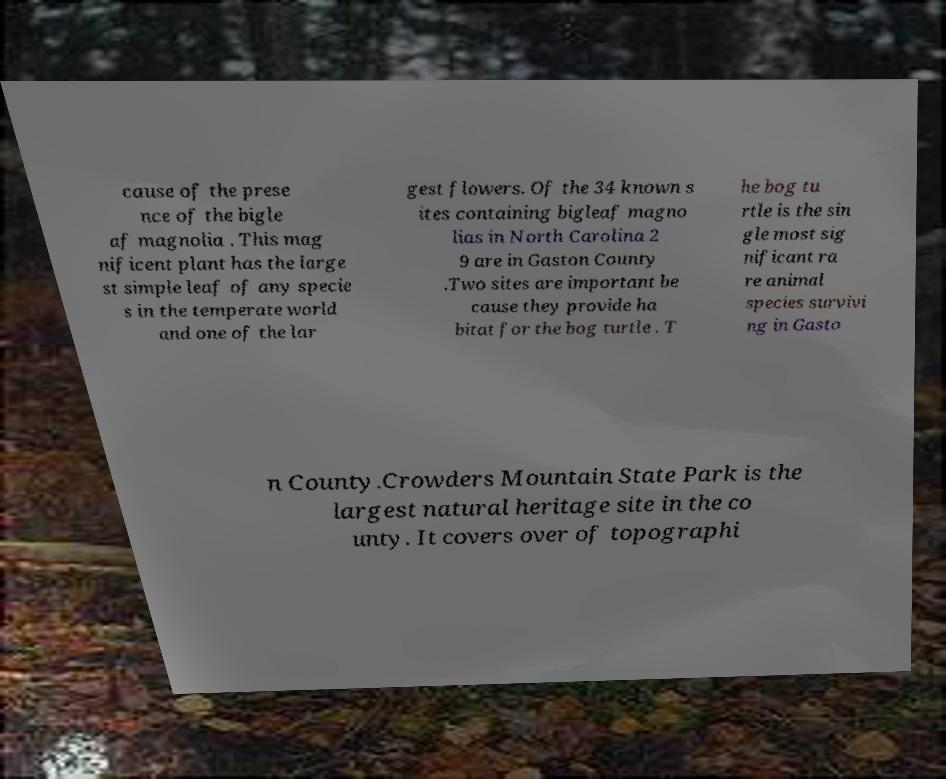Could you assist in decoding the text presented in this image and type it out clearly? cause of the prese nce of the bigle af magnolia . This mag nificent plant has the large st simple leaf of any specie s in the temperate world and one of the lar gest flowers. Of the 34 known s ites containing bigleaf magno lias in North Carolina 2 9 are in Gaston County .Two sites are important be cause they provide ha bitat for the bog turtle . T he bog tu rtle is the sin gle most sig nificant ra re animal species survivi ng in Gasto n County.Crowders Mountain State Park is the largest natural heritage site in the co unty. It covers over of topographi 